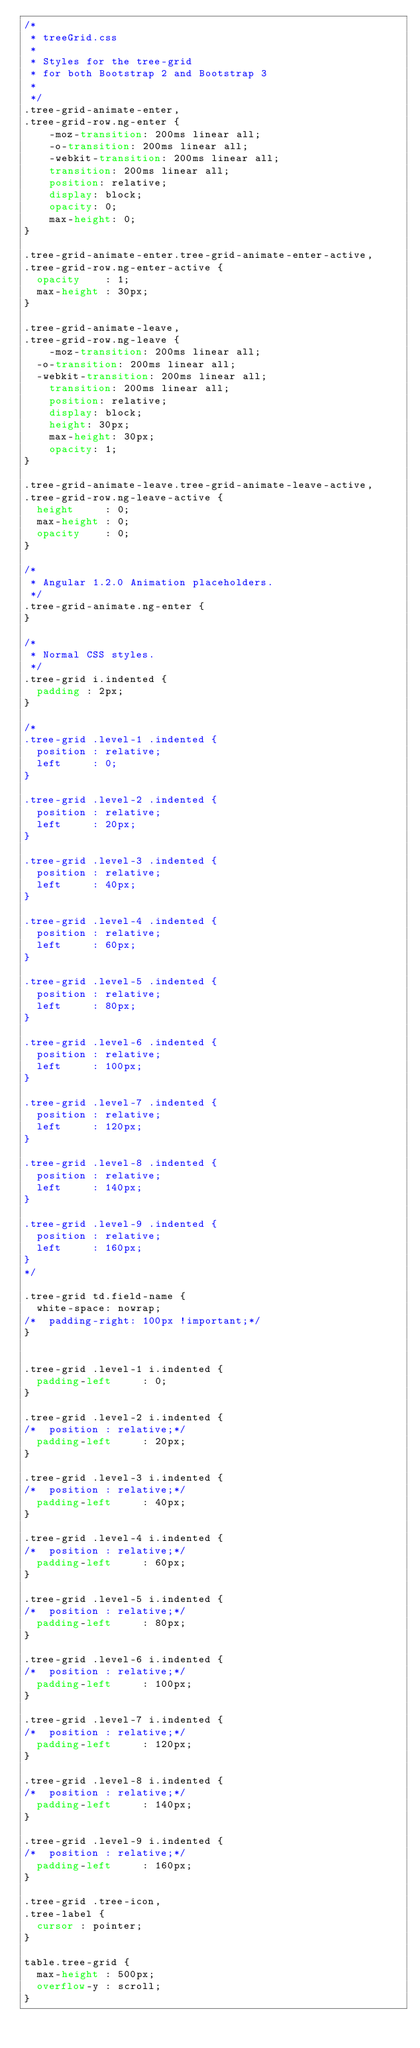Convert code to text. <code><loc_0><loc_0><loc_500><loc_500><_CSS_>/* 
 * treeGrid.css
 *
 * Styles for the tree-grid
 * for both Bootstrap 2 and Bootstrap 3
 *
 */
.tree-grid-animate-enter,
.tree-grid-row.ng-enter {
    -moz-transition: 200ms linear all;
    -o-transition: 200ms linear all;
    -webkit-transition: 200ms linear all;
    transition: 200ms linear all;
    position: relative;
    display: block;
    opacity: 0;
    max-height: 0;
}

.tree-grid-animate-enter.tree-grid-animate-enter-active,
.tree-grid-row.ng-enter-active {
	opacity    : 1;
	max-height : 30px;
}

.tree-grid-animate-leave,
.tree-grid-row.ng-leave {
    -moz-transition: 200ms linear all;
	-o-transition: 200ms linear all;
	-webkit-transition: 200ms linear all;
    transition: 200ms linear all;
    position: relative;
    display: block;
    height: 30px;
    max-height: 30px;
    opacity: 1;
}

.tree-grid-animate-leave.tree-grid-animate-leave-active,
.tree-grid-row.ng-leave-active {
	height     : 0;
	max-height : 0;
	opacity    : 0;
}

/*
 * Angular 1.2.0 Animation placeholders.
 */
.tree-grid-animate.ng-enter {
}

/*
 * Normal CSS styles.
 */
.tree-grid i.indented {
	padding : 2px;
}

/*
.tree-grid .level-1 .indented {
	position : relative;
	left     : 0;
}

.tree-grid .level-2 .indented {
	position : relative;
	left     : 20px;
}

.tree-grid .level-3 .indented {
	position : relative;
	left     : 40px;
}

.tree-grid .level-4 .indented {
	position : relative;
	left     : 60px;
}

.tree-grid .level-5 .indented {
	position : relative;
	left     : 80px;
}

.tree-grid .level-6 .indented {
	position : relative;
	left     : 100px;
}

.tree-grid .level-7 .indented {
	position : relative;
	left     : 120px;
}

.tree-grid .level-8 .indented {
	position : relative;
	left     : 140px;
}

.tree-grid .level-9 .indented {
	position : relative;
	left     : 160px;
}
*/

.tree-grid td.field-name {
  white-space: nowrap;
/*  padding-right: 100px !important;*/
}


.tree-grid .level-1 i.indented {
	padding-left     : 0;
}

.tree-grid .level-2 i.indented {
/*	position : relative;*/
	padding-left     : 20px;
}

.tree-grid .level-3 i.indented {
/*	position : relative;*/
	padding-left     : 40px;
}

.tree-grid .level-4 i.indented {
/*	position : relative;*/
	padding-left     : 60px;
}

.tree-grid .level-5 i.indented {
/*	position : relative;*/
	padding-left     : 80px;
}

.tree-grid .level-6 i.indented {
/*	position : relative;*/
	padding-left     : 100px;
}

.tree-grid .level-7 i.indented {
/*	position : relative;*/
	padding-left     : 120px;
}

.tree-grid .level-8 i.indented {
/*	position : relative;*/
	padding-left     : 140px;
}

.tree-grid .level-9 i.indented {
/*	position : relative;*/
	padding-left     : 160px;
}

.tree-grid .tree-icon,
.tree-label {
	cursor : pointer;
}

table.tree-grid {
	max-height : 500px;
	overflow-y : scroll;
}</code> 